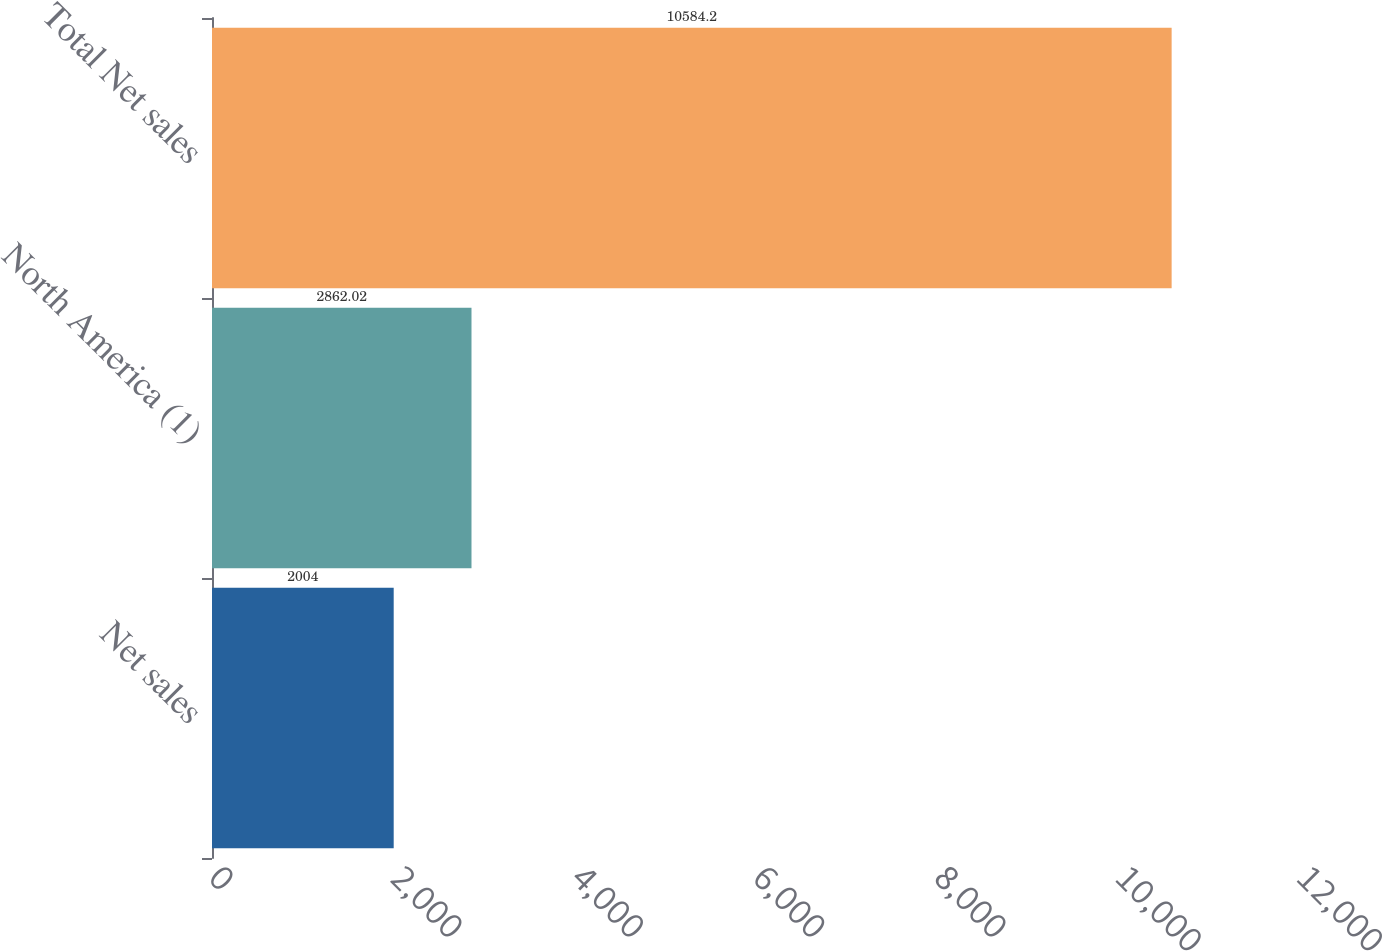Convert chart. <chart><loc_0><loc_0><loc_500><loc_500><bar_chart><fcel>Net sales<fcel>North America (1)<fcel>Total Net sales<nl><fcel>2004<fcel>2862.02<fcel>10584.2<nl></chart> 